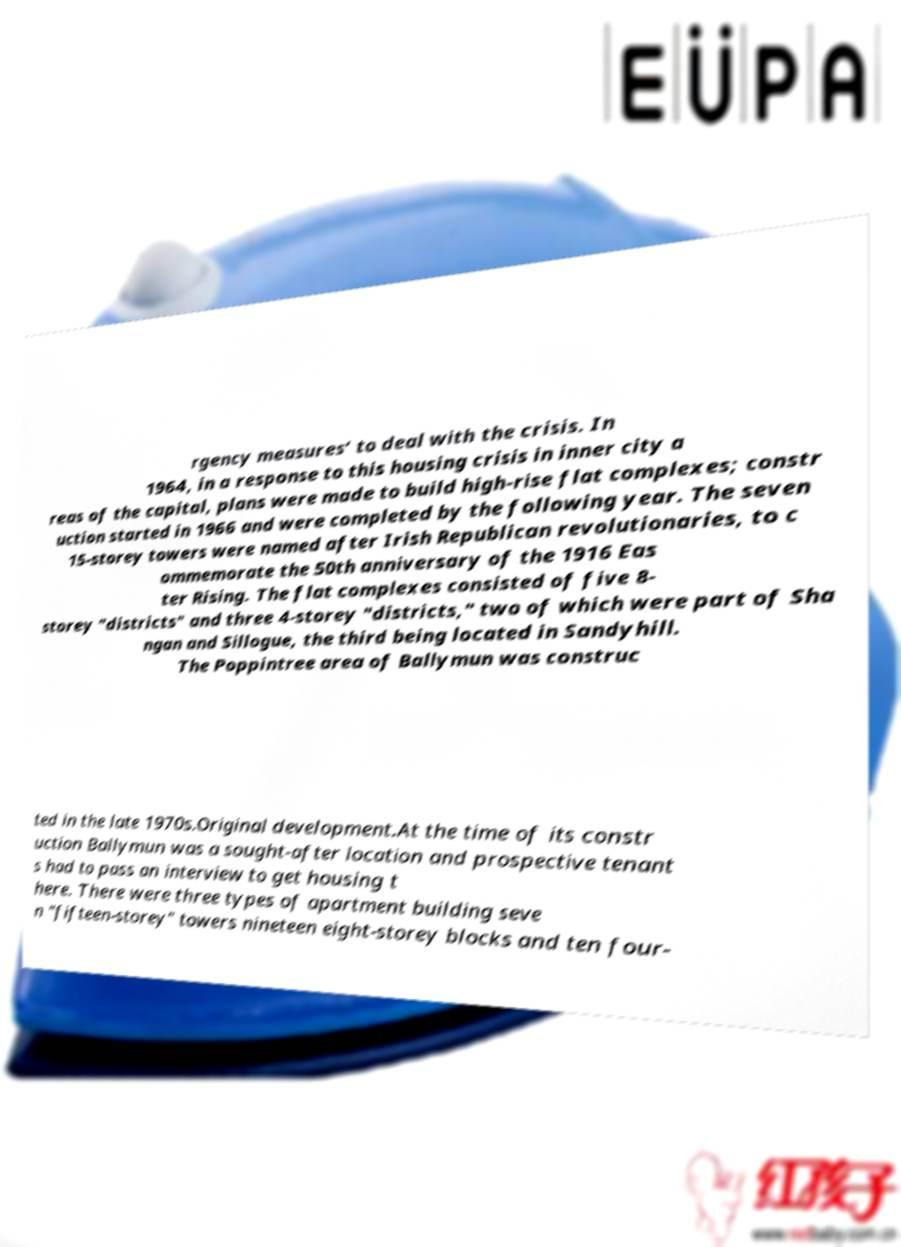There's text embedded in this image that I need extracted. Can you transcribe it verbatim? rgency measures’ to deal with the crisis. In 1964, in a response to this housing crisis in inner city a reas of the capital, plans were made to build high-rise flat complexes; constr uction started in 1966 and were completed by the following year. The seven 15-storey towers were named after Irish Republican revolutionaries, to c ommemorate the 50th anniversary of the 1916 Eas ter Rising. The flat complexes consisted of five 8- storey "districts" and three 4-storey "districts," two of which were part of Sha ngan and Sillogue, the third being located in Sandyhill. The Poppintree area of Ballymun was construc ted in the late 1970s.Original development.At the time of its constr uction Ballymun was a sought-after location and prospective tenant s had to pass an interview to get housing t here. There were three types of apartment building seve n "fifteen-storey" towers nineteen eight-storey blocks and ten four- 